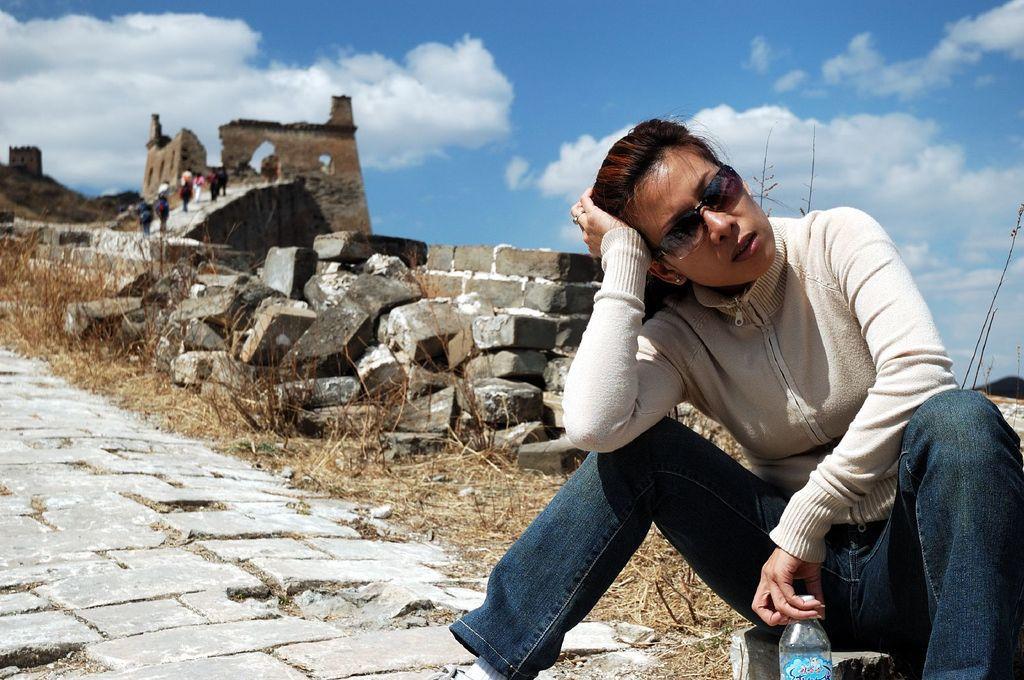Describe this image in one or two sentences. In this image we can see there is a girl sitting on the rock behind that there is a fort where so many people are walking on it. 